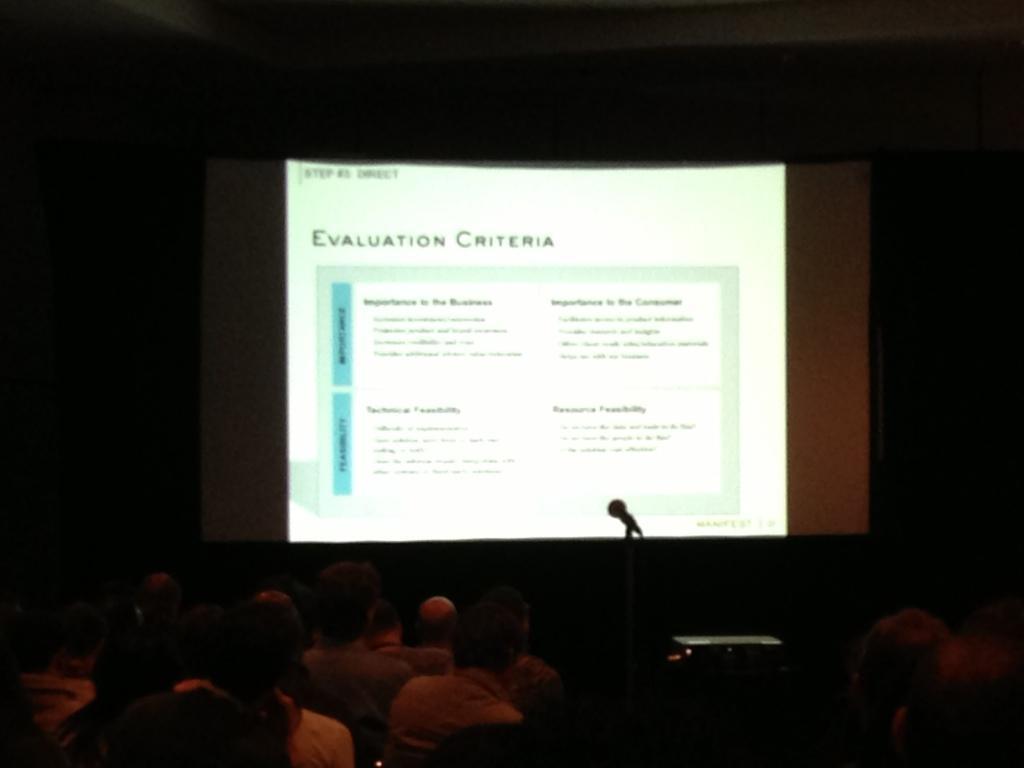Could you give a brief overview of what you see in this image? In this image we can see few persons are sitting on the chairs, projector on a stand, screen, mic on a stand and in the background the image is dark. 